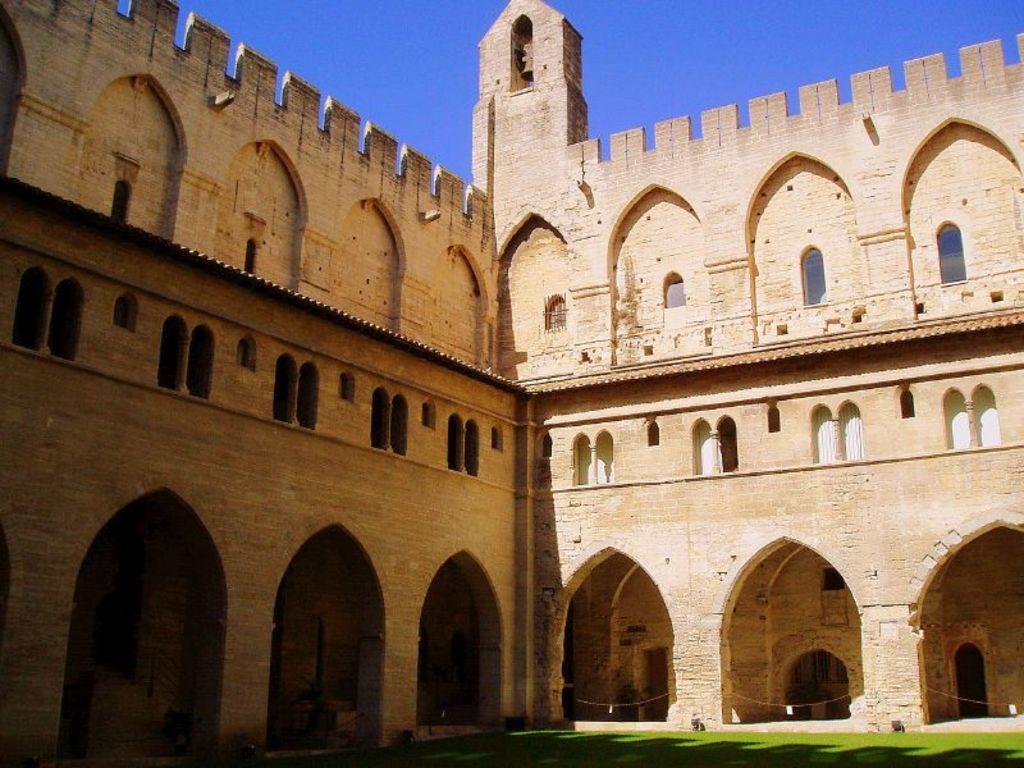Please provide a concise description of this image. In this image, we can see a fort and we can see some ropes. At the top, there is sky and at the bottom, there is ground. 